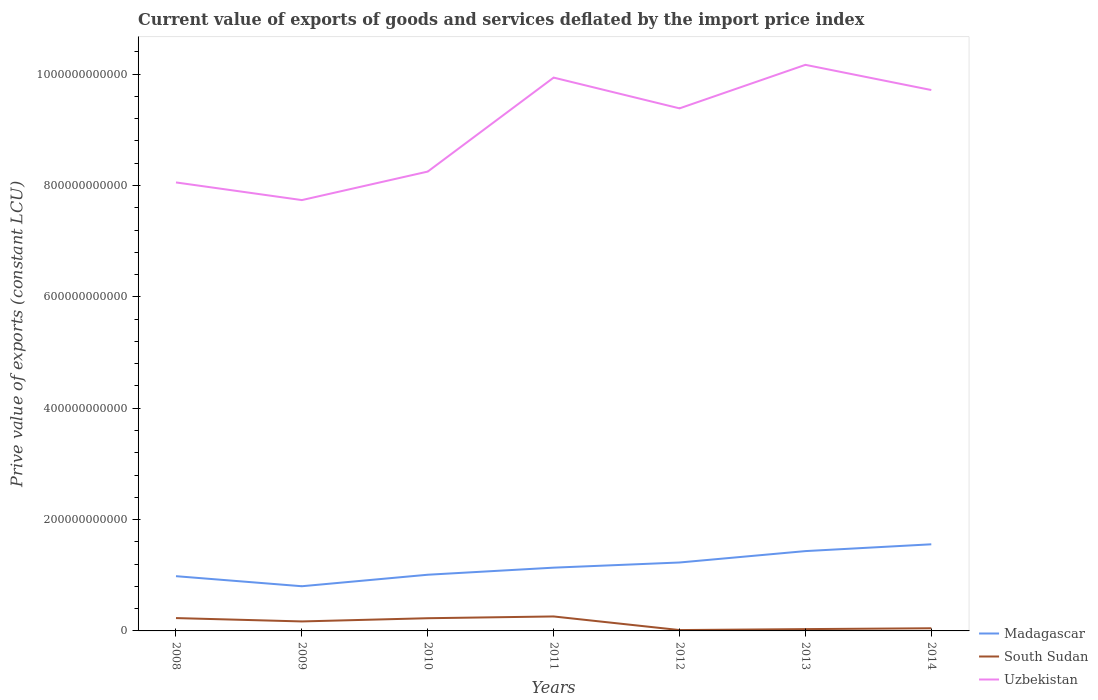How many different coloured lines are there?
Give a very brief answer. 3. Across all years, what is the maximum prive value of exports in South Sudan?
Your response must be concise. 1.55e+09. In which year was the prive value of exports in Uzbekistan maximum?
Make the answer very short. 2009. What is the total prive value of exports in South Sudan in the graph?
Offer a terse response. 2.44e+1. What is the difference between the highest and the second highest prive value of exports in Uzbekistan?
Keep it short and to the point. 2.43e+11. How many lines are there?
Keep it short and to the point. 3. How many years are there in the graph?
Ensure brevity in your answer.  7. What is the difference between two consecutive major ticks on the Y-axis?
Keep it short and to the point. 2.00e+11. Are the values on the major ticks of Y-axis written in scientific E-notation?
Make the answer very short. No. Does the graph contain any zero values?
Offer a very short reply. No. Does the graph contain grids?
Provide a succinct answer. No. Where does the legend appear in the graph?
Make the answer very short. Bottom right. How are the legend labels stacked?
Your answer should be compact. Vertical. What is the title of the graph?
Offer a very short reply. Current value of exports of goods and services deflated by the import price index. What is the label or title of the Y-axis?
Give a very brief answer. Prive value of exports (constant LCU). What is the Prive value of exports (constant LCU) in Madagascar in 2008?
Your answer should be compact. 9.83e+1. What is the Prive value of exports (constant LCU) of South Sudan in 2008?
Your response must be concise. 2.31e+1. What is the Prive value of exports (constant LCU) of Uzbekistan in 2008?
Keep it short and to the point. 8.05e+11. What is the Prive value of exports (constant LCU) in Madagascar in 2009?
Offer a terse response. 8.03e+1. What is the Prive value of exports (constant LCU) in South Sudan in 2009?
Offer a terse response. 1.70e+1. What is the Prive value of exports (constant LCU) in Uzbekistan in 2009?
Ensure brevity in your answer.  7.74e+11. What is the Prive value of exports (constant LCU) in Madagascar in 2010?
Provide a succinct answer. 1.01e+11. What is the Prive value of exports (constant LCU) in South Sudan in 2010?
Provide a short and direct response. 2.28e+1. What is the Prive value of exports (constant LCU) of Uzbekistan in 2010?
Your answer should be very brief. 8.25e+11. What is the Prive value of exports (constant LCU) of Madagascar in 2011?
Provide a succinct answer. 1.14e+11. What is the Prive value of exports (constant LCU) of South Sudan in 2011?
Keep it short and to the point. 2.60e+1. What is the Prive value of exports (constant LCU) of Uzbekistan in 2011?
Offer a very short reply. 9.94e+11. What is the Prive value of exports (constant LCU) of Madagascar in 2012?
Ensure brevity in your answer.  1.23e+11. What is the Prive value of exports (constant LCU) in South Sudan in 2012?
Your answer should be compact. 1.55e+09. What is the Prive value of exports (constant LCU) of Uzbekistan in 2012?
Keep it short and to the point. 9.38e+11. What is the Prive value of exports (constant LCU) of Madagascar in 2013?
Offer a terse response. 1.43e+11. What is the Prive value of exports (constant LCU) in South Sudan in 2013?
Offer a terse response. 3.25e+09. What is the Prive value of exports (constant LCU) of Uzbekistan in 2013?
Make the answer very short. 1.02e+12. What is the Prive value of exports (constant LCU) of Madagascar in 2014?
Your response must be concise. 1.56e+11. What is the Prive value of exports (constant LCU) of South Sudan in 2014?
Your answer should be very brief. 4.76e+09. What is the Prive value of exports (constant LCU) in Uzbekistan in 2014?
Offer a terse response. 9.71e+11. Across all years, what is the maximum Prive value of exports (constant LCU) of Madagascar?
Provide a short and direct response. 1.56e+11. Across all years, what is the maximum Prive value of exports (constant LCU) in South Sudan?
Make the answer very short. 2.60e+1. Across all years, what is the maximum Prive value of exports (constant LCU) in Uzbekistan?
Offer a very short reply. 1.02e+12. Across all years, what is the minimum Prive value of exports (constant LCU) of Madagascar?
Give a very brief answer. 8.03e+1. Across all years, what is the minimum Prive value of exports (constant LCU) of South Sudan?
Provide a succinct answer. 1.55e+09. Across all years, what is the minimum Prive value of exports (constant LCU) in Uzbekistan?
Make the answer very short. 7.74e+11. What is the total Prive value of exports (constant LCU) in Madagascar in the graph?
Provide a short and direct response. 8.15e+11. What is the total Prive value of exports (constant LCU) in South Sudan in the graph?
Offer a terse response. 9.85e+1. What is the total Prive value of exports (constant LCU) of Uzbekistan in the graph?
Your response must be concise. 6.32e+12. What is the difference between the Prive value of exports (constant LCU) in Madagascar in 2008 and that in 2009?
Make the answer very short. 1.81e+1. What is the difference between the Prive value of exports (constant LCU) in South Sudan in 2008 and that in 2009?
Offer a very short reply. 6.03e+09. What is the difference between the Prive value of exports (constant LCU) of Uzbekistan in 2008 and that in 2009?
Your response must be concise. 3.17e+1. What is the difference between the Prive value of exports (constant LCU) in Madagascar in 2008 and that in 2010?
Keep it short and to the point. -2.60e+09. What is the difference between the Prive value of exports (constant LCU) in South Sudan in 2008 and that in 2010?
Your answer should be very brief. 2.50e+08. What is the difference between the Prive value of exports (constant LCU) of Uzbekistan in 2008 and that in 2010?
Your answer should be very brief. -1.95e+1. What is the difference between the Prive value of exports (constant LCU) of Madagascar in 2008 and that in 2011?
Your answer should be very brief. -1.53e+1. What is the difference between the Prive value of exports (constant LCU) of South Sudan in 2008 and that in 2011?
Give a very brief answer. -2.90e+09. What is the difference between the Prive value of exports (constant LCU) of Uzbekistan in 2008 and that in 2011?
Keep it short and to the point. -1.88e+11. What is the difference between the Prive value of exports (constant LCU) in Madagascar in 2008 and that in 2012?
Provide a short and direct response. -2.46e+1. What is the difference between the Prive value of exports (constant LCU) in South Sudan in 2008 and that in 2012?
Make the answer very short. 2.15e+1. What is the difference between the Prive value of exports (constant LCU) in Uzbekistan in 2008 and that in 2012?
Keep it short and to the point. -1.33e+11. What is the difference between the Prive value of exports (constant LCU) in Madagascar in 2008 and that in 2013?
Your response must be concise. -4.50e+1. What is the difference between the Prive value of exports (constant LCU) in South Sudan in 2008 and that in 2013?
Ensure brevity in your answer.  1.98e+1. What is the difference between the Prive value of exports (constant LCU) of Uzbekistan in 2008 and that in 2013?
Your response must be concise. -2.11e+11. What is the difference between the Prive value of exports (constant LCU) in Madagascar in 2008 and that in 2014?
Give a very brief answer. -5.73e+1. What is the difference between the Prive value of exports (constant LCU) in South Sudan in 2008 and that in 2014?
Provide a succinct answer. 1.83e+1. What is the difference between the Prive value of exports (constant LCU) in Uzbekistan in 2008 and that in 2014?
Provide a short and direct response. -1.66e+11. What is the difference between the Prive value of exports (constant LCU) in Madagascar in 2009 and that in 2010?
Your answer should be very brief. -2.06e+1. What is the difference between the Prive value of exports (constant LCU) in South Sudan in 2009 and that in 2010?
Your answer should be very brief. -5.78e+09. What is the difference between the Prive value of exports (constant LCU) of Uzbekistan in 2009 and that in 2010?
Your answer should be very brief. -5.12e+1. What is the difference between the Prive value of exports (constant LCU) of Madagascar in 2009 and that in 2011?
Make the answer very short. -3.34e+1. What is the difference between the Prive value of exports (constant LCU) in South Sudan in 2009 and that in 2011?
Your response must be concise. -8.93e+09. What is the difference between the Prive value of exports (constant LCU) of Uzbekistan in 2009 and that in 2011?
Provide a short and direct response. -2.20e+11. What is the difference between the Prive value of exports (constant LCU) of Madagascar in 2009 and that in 2012?
Give a very brief answer. -4.26e+1. What is the difference between the Prive value of exports (constant LCU) of South Sudan in 2009 and that in 2012?
Offer a very short reply. 1.55e+1. What is the difference between the Prive value of exports (constant LCU) of Uzbekistan in 2009 and that in 2012?
Your answer should be very brief. -1.65e+11. What is the difference between the Prive value of exports (constant LCU) of Madagascar in 2009 and that in 2013?
Offer a terse response. -6.31e+1. What is the difference between the Prive value of exports (constant LCU) in South Sudan in 2009 and that in 2013?
Keep it short and to the point. 1.38e+1. What is the difference between the Prive value of exports (constant LCU) in Uzbekistan in 2009 and that in 2013?
Provide a succinct answer. -2.43e+11. What is the difference between the Prive value of exports (constant LCU) in Madagascar in 2009 and that in 2014?
Offer a very short reply. -7.53e+1. What is the difference between the Prive value of exports (constant LCU) in South Sudan in 2009 and that in 2014?
Make the answer very short. 1.23e+1. What is the difference between the Prive value of exports (constant LCU) in Uzbekistan in 2009 and that in 2014?
Offer a very short reply. -1.98e+11. What is the difference between the Prive value of exports (constant LCU) in Madagascar in 2010 and that in 2011?
Keep it short and to the point. -1.27e+1. What is the difference between the Prive value of exports (constant LCU) of South Sudan in 2010 and that in 2011?
Provide a succinct answer. -3.15e+09. What is the difference between the Prive value of exports (constant LCU) in Uzbekistan in 2010 and that in 2011?
Provide a short and direct response. -1.69e+11. What is the difference between the Prive value of exports (constant LCU) of Madagascar in 2010 and that in 2012?
Keep it short and to the point. -2.20e+1. What is the difference between the Prive value of exports (constant LCU) in South Sudan in 2010 and that in 2012?
Offer a very short reply. 2.13e+1. What is the difference between the Prive value of exports (constant LCU) of Uzbekistan in 2010 and that in 2012?
Make the answer very short. -1.14e+11. What is the difference between the Prive value of exports (constant LCU) of Madagascar in 2010 and that in 2013?
Your answer should be compact. -4.25e+1. What is the difference between the Prive value of exports (constant LCU) in South Sudan in 2010 and that in 2013?
Offer a very short reply. 1.96e+1. What is the difference between the Prive value of exports (constant LCU) in Uzbekistan in 2010 and that in 2013?
Make the answer very short. -1.92e+11. What is the difference between the Prive value of exports (constant LCU) of Madagascar in 2010 and that in 2014?
Your response must be concise. -5.47e+1. What is the difference between the Prive value of exports (constant LCU) in South Sudan in 2010 and that in 2014?
Offer a very short reply. 1.81e+1. What is the difference between the Prive value of exports (constant LCU) of Uzbekistan in 2010 and that in 2014?
Keep it short and to the point. -1.46e+11. What is the difference between the Prive value of exports (constant LCU) of Madagascar in 2011 and that in 2012?
Provide a short and direct response. -9.28e+09. What is the difference between the Prive value of exports (constant LCU) in South Sudan in 2011 and that in 2012?
Give a very brief answer. 2.44e+1. What is the difference between the Prive value of exports (constant LCU) of Uzbekistan in 2011 and that in 2012?
Your response must be concise. 5.53e+1. What is the difference between the Prive value of exports (constant LCU) in Madagascar in 2011 and that in 2013?
Your answer should be compact. -2.97e+1. What is the difference between the Prive value of exports (constant LCU) of South Sudan in 2011 and that in 2013?
Provide a succinct answer. 2.27e+1. What is the difference between the Prive value of exports (constant LCU) of Uzbekistan in 2011 and that in 2013?
Ensure brevity in your answer.  -2.29e+1. What is the difference between the Prive value of exports (constant LCU) in Madagascar in 2011 and that in 2014?
Your answer should be compact. -4.20e+1. What is the difference between the Prive value of exports (constant LCU) in South Sudan in 2011 and that in 2014?
Offer a terse response. 2.12e+1. What is the difference between the Prive value of exports (constant LCU) in Uzbekistan in 2011 and that in 2014?
Provide a short and direct response. 2.23e+1. What is the difference between the Prive value of exports (constant LCU) in Madagascar in 2012 and that in 2013?
Offer a very short reply. -2.05e+1. What is the difference between the Prive value of exports (constant LCU) of South Sudan in 2012 and that in 2013?
Ensure brevity in your answer.  -1.70e+09. What is the difference between the Prive value of exports (constant LCU) of Uzbekistan in 2012 and that in 2013?
Offer a very short reply. -7.82e+1. What is the difference between the Prive value of exports (constant LCU) in Madagascar in 2012 and that in 2014?
Ensure brevity in your answer.  -3.27e+1. What is the difference between the Prive value of exports (constant LCU) of South Sudan in 2012 and that in 2014?
Offer a terse response. -3.22e+09. What is the difference between the Prive value of exports (constant LCU) in Uzbekistan in 2012 and that in 2014?
Your answer should be very brief. -3.29e+1. What is the difference between the Prive value of exports (constant LCU) in Madagascar in 2013 and that in 2014?
Offer a terse response. -1.22e+1. What is the difference between the Prive value of exports (constant LCU) in South Sudan in 2013 and that in 2014?
Your answer should be very brief. -1.51e+09. What is the difference between the Prive value of exports (constant LCU) in Uzbekistan in 2013 and that in 2014?
Keep it short and to the point. 4.52e+1. What is the difference between the Prive value of exports (constant LCU) of Madagascar in 2008 and the Prive value of exports (constant LCU) of South Sudan in 2009?
Your response must be concise. 8.13e+1. What is the difference between the Prive value of exports (constant LCU) in Madagascar in 2008 and the Prive value of exports (constant LCU) in Uzbekistan in 2009?
Keep it short and to the point. -6.75e+11. What is the difference between the Prive value of exports (constant LCU) in South Sudan in 2008 and the Prive value of exports (constant LCU) in Uzbekistan in 2009?
Keep it short and to the point. -7.51e+11. What is the difference between the Prive value of exports (constant LCU) of Madagascar in 2008 and the Prive value of exports (constant LCU) of South Sudan in 2010?
Provide a short and direct response. 7.55e+1. What is the difference between the Prive value of exports (constant LCU) of Madagascar in 2008 and the Prive value of exports (constant LCU) of Uzbekistan in 2010?
Give a very brief answer. -7.27e+11. What is the difference between the Prive value of exports (constant LCU) of South Sudan in 2008 and the Prive value of exports (constant LCU) of Uzbekistan in 2010?
Your response must be concise. -8.02e+11. What is the difference between the Prive value of exports (constant LCU) in Madagascar in 2008 and the Prive value of exports (constant LCU) in South Sudan in 2011?
Your response must be concise. 7.23e+1. What is the difference between the Prive value of exports (constant LCU) in Madagascar in 2008 and the Prive value of exports (constant LCU) in Uzbekistan in 2011?
Provide a short and direct response. -8.95e+11. What is the difference between the Prive value of exports (constant LCU) of South Sudan in 2008 and the Prive value of exports (constant LCU) of Uzbekistan in 2011?
Keep it short and to the point. -9.71e+11. What is the difference between the Prive value of exports (constant LCU) in Madagascar in 2008 and the Prive value of exports (constant LCU) in South Sudan in 2012?
Offer a very short reply. 9.68e+1. What is the difference between the Prive value of exports (constant LCU) in Madagascar in 2008 and the Prive value of exports (constant LCU) in Uzbekistan in 2012?
Keep it short and to the point. -8.40e+11. What is the difference between the Prive value of exports (constant LCU) in South Sudan in 2008 and the Prive value of exports (constant LCU) in Uzbekistan in 2012?
Keep it short and to the point. -9.15e+11. What is the difference between the Prive value of exports (constant LCU) of Madagascar in 2008 and the Prive value of exports (constant LCU) of South Sudan in 2013?
Provide a short and direct response. 9.51e+1. What is the difference between the Prive value of exports (constant LCU) of Madagascar in 2008 and the Prive value of exports (constant LCU) of Uzbekistan in 2013?
Ensure brevity in your answer.  -9.18e+11. What is the difference between the Prive value of exports (constant LCU) in South Sudan in 2008 and the Prive value of exports (constant LCU) in Uzbekistan in 2013?
Your answer should be compact. -9.94e+11. What is the difference between the Prive value of exports (constant LCU) in Madagascar in 2008 and the Prive value of exports (constant LCU) in South Sudan in 2014?
Keep it short and to the point. 9.36e+1. What is the difference between the Prive value of exports (constant LCU) in Madagascar in 2008 and the Prive value of exports (constant LCU) in Uzbekistan in 2014?
Provide a succinct answer. -8.73e+11. What is the difference between the Prive value of exports (constant LCU) in South Sudan in 2008 and the Prive value of exports (constant LCU) in Uzbekistan in 2014?
Provide a succinct answer. -9.48e+11. What is the difference between the Prive value of exports (constant LCU) of Madagascar in 2009 and the Prive value of exports (constant LCU) of South Sudan in 2010?
Offer a very short reply. 5.74e+1. What is the difference between the Prive value of exports (constant LCU) in Madagascar in 2009 and the Prive value of exports (constant LCU) in Uzbekistan in 2010?
Provide a succinct answer. -7.45e+11. What is the difference between the Prive value of exports (constant LCU) of South Sudan in 2009 and the Prive value of exports (constant LCU) of Uzbekistan in 2010?
Offer a terse response. -8.08e+11. What is the difference between the Prive value of exports (constant LCU) of Madagascar in 2009 and the Prive value of exports (constant LCU) of South Sudan in 2011?
Give a very brief answer. 5.43e+1. What is the difference between the Prive value of exports (constant LCU) in Madagascar in 2009 and the Prive value of exports (constant LCU) in Uzbekistan in 2011?
Ensure brevity in your answer.  -9.13e+11. What is the difference between the Prive value of exports (constant LCU) in South Sudan in 2009 and the Prive value of exports (constant LCU) in Uzbekistan in 2011?
Ensure brevity in your answer.  -9.77e+11. What is the difference between the Prive value of exports (constant LCU) in Madagascar in 2009 and the Prive value of exports (constant LCU) in South Sudan in 2012?
Provide a short and direct response. 7.87e+1. What is the difference between the Prive value of exports (constant LCU) in Madagascar in 2009 and the Prive value of exports (constant LCU) in Uzbekistan in 2012?
Ensure brevity in your answer.  -8.58e+11. What is the difference between the Prive value of exports (constant LCU) in South Sudan in 2009 and the Prive value of exports (constant LCU) in Uzbekistan in 2012?
Give a very brief answer. -9.21e+11. What is the difference between the Prive value of exports (constant LCU) in Madagascar in 2009 and the Prive value of exports (constant LCU) in South Sudan in 2013?
Your response must be concise. 7.70e+1. What is the difference between the Prive value of exports (constant LCU) in Madagascar in 2009 and the Prive value of exports (constant LCU) in Uzbekistan in 2013?
Your response must be concise. -9.36e+11. What is the difference between the Prive value of exports (constant LCU) of South Sudan in 2009 and the Prive value of exports (constant LCU) of Uzbekistan in 2013?
Your answer should be compact. -1.00e+12. What is the difference between the Prive value of exports (constant LCU) of Madagascar in 2009 and the Prive value of exports (constant LCU) of South Sudan in 2014?
Offer a terse response. 7.55e+1. What is the difference between the Prive value of exports (constant LCU) in Madagascar in 2009 and the Prive value of exports (constant LCU) in Uzbekistan in 2014?
Provide a short and direct response. -8.91e+11. What is the difference between the Prive value of exports (constant LCU) in South Sudan in 2009 and the Prive value of exports (constant LCU) in Uzbekistan in 2014?
Provide a succinct answer. -9.54e+11. What is the difference between the Prive value of exports (constant LCU) in Madagascar in 2010 and the Prive value of exports (constant LCU) in South Sudan in 2011?
Your response must be concise. 7.49e+1. What is the difference between the Prive value of exports (constant LCU) of Madagascar in 2010 and the Prive value of exports (constant LCU) of Uzbekistan in 2011?
Your response must be concise. -8.93e+11. What is the difference between the Prive value of exports (constant LCU) in South Sudan in 2010 and the Prive value of exports (constant LCU) in Uzbekistan in 2011?
Make the answer very short. -9.71e+11. What is the difference between the Prive value of exports (constant LCU) of Madagascar in 2010 and the Prive value of exports (constant LCU) of South Sudan in 2012?
Your response must be concise. 9.94e+1. What is the difference between the Prive value of exports (constant LCU) of Madagascar in 2010 and the Prive value of exports (constant LCU) of Uzbekistan in 2012?
Your response must be concise. -8.38e+11. What is the difference between the Prive value of exports (constant LCU) in South Sudan in 2010 and the Prive value of exports (constant LCU) in Uzbekistan in 2012?
Offer a terse response. -9.16e+11. What is the difference between the Prive value of exports (constant LCU) in Madagascar in 2010 and the Prive value of exports (constant LCU) in South Sudan in 2013?
Offer a very short reply. 9.77e+1. What is the difference between the Prive value of exports (constant LCU) of Madagascar in 2010 and the Prive value of exports (constant LCU) of Uzbekistan in 2013?
Ensure brevity in your answer.  -9.16e+11. What is the difference between the Prive value of exports (constant LCU) in South Sudan in 2010 and the Prive value of exports (constant LCU) in Uzbekistan in 2013?
Your answer should be very brief. -9.94e+11. What is the difference between the Prive value of exports (constant LCU) of Madagascar in 2010 and the Prive value of exports (constant LCU) of South Sudan in 2014?
Your answer should be very brief. 9.61e+1. What is the difference between the Prive value of exports (constant LCU) of Madagascar in 2010 and the Prive value of exports (constant LCU) of Uzbekistan in 2014?
Give a very brief answer. -8.71e+11. What is the difference between the Prive value of exports (constant LCU) in South Sudan in 2010 and the Prive value of exports (constant LCU) in Uzbekistan in 2014?
Provide a short and direct response. -9.49e+11. What is the difference between the Prive value of exports (constant LCU) of Madagascar in 2011 and the Prive value of exports (constant LCU) of South Sudan in 2012?
Provide a succinct answer. 1.12e+11. What is the difference between the Prive value of exports (constant LCU) in Madagascar in 2011 and the Prive value of exports (constant LCU) in Uzbekistan in 2012?
Offer a very short reply. -8.25e+11. What is the difference between the Prive value of exports (constant LCU) of South Sudan in 2011 and the Prive value of exports (constant LCU) of Uzbekistan in 2012?
Your answer should be compact. -9.13e+11. What is the difference between the Prive value of exports (constant LCU) of Madagascar in 2011 and the Prive value of exports (constant LCU) of South Sudan in 2013?
Provide a succinct answer. 1.10e+11. What is the difference between the Prive value of exports (constant LCU) of Madagascar in 2011 and the Prive value of exports (constant LCU) of Uzbekistan in 2013?
Keep it short and to the point. -9.03e+11. What is the difference between the Prive value of exports (constant LCU) of South Sudan in 2011 and the Prive value of exports (constant LCU) of Uzbekistan in 2013?
Offer a very short reply. -9.91e+11. What is the difference between the Prive value of exports (constant LCU) in Madagascar in 2011 and the Prive value of exports (constant LCU) in South Sudan in 2014?
Keep it short and to the point. 1.09e+11. What is the difference between the Prive value of exports (constant LCU) of Madagascar in 2011 and the Prive value of exports (constant LCU) of Uzbekistan in 2014?
Provide a succinct answer. -8.58e+11. What is the difference between the Prive value of exports (constant LCU) in South Sudan in 2011 and the Prive value of exports (constant LCU) in Uzbekistan in 2014?
Provide a succinct answer. -9.45e+11. What is the difference between the Prive value of exports (constant LCU) in Madagascar in 2012 and the Prive value of exports (constant LCU) in South Sudan in 2013?
Make the answer very short. 1.20e+11. What is the difference between the Prive value of exports (constant LCU) in Madagascar in 2012 and the Prive value of exports (constant LCU) in Uzbekistan in 2013?
Offer a terse response. -8.94e+11. What is the difference between the Prive value of exports (constant LCU) of South Sudan in 2012 and the Prive value of exports (constant LCU) of Uzbekistan in 2013?
Make the answer very short. -1.02e+12. What is the difference between the Prive value of exports (constant LCU) of Madagascar in 2012 and the Prive value of exports (constant LCU) of South Sudan in 2014?
Offer a very short reply. 1.18e+11. What is the difference between the Prive value of exports (constant LCU) in Madagascar in 2012 and the Prive value of exports (constant LCU) in Uzbekistan in 2014?
Your response must be concise. -8.49e+11. What is the difference between the Prive value of exports (constant LCU) of South Sudan in 2012 and the Prive value of exports (constant LCU) of Uzbekistan in 2014?
Provide a short and direct response. -9.70e+11. What is the difference between the Prive value of exports (constant LCU) of Madagascar in 2013 and the Prive value of exports (constant LCU) of South Sudan in 2014?
Keep it short and to the point. 1.39e+11. What is the difference between the Prive value of exports (constant LCU) in Madagascar in 2013 and the Prive value of exports (constant LCU) in Uzbekistan in 2014?
Provide a short and direct response. -8.28e+11. What is the difference between the Prive value of exports (constant LCU) of South Sudan in 2013 and the Prive value of exports (constant LCU) of Uzbekistan in 2014?
Your answer should be very brief. -9.68e+11. What is the average Prive value of exports (constant LCU) in Madagascar per year?
Offer a terse response. 1.16e+11. What is the average Prive value of exports (constant LCU) of South Sudan per year?
Provide a short and direct response. 1.41e+1. What is the average Prive value of exports (constant LCU) of Uzbekistan per year?
Provide a succinct answer. 9.04e+11. In the year 2008, what is the difference between the Prive value of exports (constant LCU) in Madagascar and Prive value of exports (constant LCU) in South Sudan?
Keep it short and to the point. 7.52e+1. In the year 2008, what is the difference between the Prive value of exports (constant LCU) of Madagascar and Prive value of exports (constant LCU) of Uzbekistan?
Provide a succinct answer. -7.07e+11. In the year 2008, what is the difference between the Prive value of exports (constant LCU) in South Sudan and Prive value of exports (constant LCU) in Uzbekistan?
Your answer should be compact. -7.82e+11. In the year 2009, what is the difference between the Prive value of exports (constant LCU) of Madagascar and Prive value of exports (constant LCU) of South Sudan?
Offer a terse response. 6.32e+1. In the year 2009, what is the difference between the Prive value of exports (constant LCU) of Madagascar and Prive value of exports (constant LCU) of Uzbekistan?
Keep it short and to the point. -6.93e+11. In the year 2009, what is the difference between the Prive value of exports (constant LCU) of South Sudan and Prive value of exports (constant LCU) of Uzbekistan?
Provide a short and direct response. -7.57e+11. In the year 2010, what is the difference between the Prive value of exports (constant LCU) in Madagascar and Prive value of exports (constant LCU) in South Sudan?
Provide a succinct answer. 7.81e+1. In the year 2010, what is the difference between the Prive value of exports (constant LCU) of Madagascar and Prive value of exports (constant LCU) of Uzbekistan?
Provide a succinct answer. -7.24e+11. In the year 2010, what is the difference between the Prive value of exports (constant LCU) in South Sudan and Prive value of exports (constant LCU) in Uzbekistan?
Ensure brevity in your answer.  -8.02e+11. In the year 2011, what is the difference between the Prive value of exports (constant LCU) of Madagascar and Prive value of exports (constant LCU) of South Sudan?
Provide a succinct answer. 8.76e+1. In the year 2011, what is the difference between the Prive value of exports (constant LCU) of Madagascar and Prive value of exports (constant LCU) of Uzbekistan?
Provide a short and direct response. -8.80e+11. In the year 2011, what is the difference between the Prive value of exports (constant LCU) in South Sudan and Prive value of exports (constant LCU) in Uzbekistan?
Offer a terse response. -9.68e+11. In the year 2012, what is the difference between the Prive value of exports (constant LCU) of Madagascar and Prive value of exports (constant LCU) of South Sudan?
Provide a short and direct response. 1.21e+11. In the year 2012, what is the difference between the Prive value of exports (constant LCU) in Madagascar and Prive value of exports (constant LCU) in Uzbekistan?
Your answer should be very brief. -8.16e+11. In the year 2012, what is the difference between the Prive value of exports (constant LCU) in South Sudan and Prive value of exports (constant LCU) in Uzbekistan?
Your answer should be very brief. -9.37e+11. In the year 2013, what is the difference between the Prive value of exports (constant LCU) of Madagascar and Prive value of exports (constant LCU) of South Sudan?
Ensure brevity in your answer.  1.40e+11. In the year 2013, what is the difference between the Prive value of exports (constant LCU) in Madagascar and Prive value of exports (constant LCU) in Uzbekistan?
Offer a terse response. -8.73e+11. In the year 2013, what is the difference between the Prive value of exports (constant LCU) in South Sudan and Prive value of exports (constant LCU) in Uzbekistan?
Your answer should be compact. -1.01e+12. In the year 2014, what is the difference between the Prive value of exports (constant LCU) in Madagascar and Prive value of exports (constant LCU) in South Sudan?
Your answer should be very brief. 1.51e+11. In the year 2014, what is the difference between the Prive value of exports (constant LCU) of Madagascar and Prive value of exports (constant LCU) of Uzbekistan?
Keep it short and to the point. -8.16e+11. In the year 2014, what is the difference between the Prive value of exports (constant LCU) in South Sudan and Prive value of exports (constant LCU) in Uzbekistan?
Make the answer very short. -9.67e+11. What is the ratio of the Prive value of exports (constant LCU) in Madagascar in 2008 to that in 2009?
Offer a terse response. 1.22. What is the ratio of the Prive value of exports (constant LCU) of South Sudan in 2008 to that in 2009?
Keep it short and to the point. 1.35. What is the ratio of the Prive value of exports (constant LCU) in Uzbekistan in 2008 to that in 2009?
Provide a succinct answer. 1.04. What is the ratio of the Prive value of exports (constant LCU) in Madagascar in 2008 to that in 2010?
Ensure brevity in your answer.  0.97. What is the ratio of the Prive value of exports (constant LCU) in Uzbekistan in 2008 to that in 2010?
Ensure brevity in your answer.  0.98. What is the ratio of the Prive value of exports (constant LCU) in Madagascar in 2008 to that in 2011?
Your answer should be very brief. 0.87. What is the ratio of the Prive value of exports (constant LCU) in South Sudan in 2008 to that in 2011?
Offer a very short reply. 0.89. What is the ratio of the Prive value of exports (constant LCU) in Uzbekistan in 2008 to that in 2011?
Make the answer very short. 0.81. What is the ratio of the Prive value of exports (constant LCU) in Madagascar in 2008 to that in 2012?
Give a very brief answer. 0.8. What is the ratio of the Prive value of exports (constant LCU) in South Sudan in 2008 to that in 2012?
Keep it short and to the point. 14.93. What is the ratio of the Prive value of exports (constant LCU) of Uzbekistan in 2008 to that in 2012?
Make the answer very short. 0.86. What is the ratio of the Prive value of exports (constant LCU) of Madagascar in 2008 to that in 2013?
Provide a short and direct response. 0.69. What is the ratio of the Prive value of exports (constant LCU) of South Sudan in 2008 to that in 2013?
Ensure brevity in your answer.  7.1. What is the ratio of the Prive value of exports (constant LCU) in Uzbekistan in 2008 to that in 2013?
Ensure brevity in your answer.  0.79. What is the ratio of the Prive value of exports (constant LCU) in Madagascar in 2008 to that in 2014?
Provide a short and direct response. 0.63. What is the ratio of the Prive value of exports (constant LCU) in South Sudan in 2008 to that in 2014?
Provide a succinct answer. 4.84. What is the ratio of the Prive value of exports (constant LCU) in Uzbekistan in 2008 to that in 2014?
Make the answer very short. 0.83. What is the ratio of the Prive value of exports (constant LCU) of Madagascar in 2009 to that in 2010?
Your response must be concise. 0.8. What is the ratio of the Prive value of exports (constant LCU) in South Sudan in 2009 to that in 2010?
Your answer should be very brief. 0.75. What is the ratio of the Prive value of exports (constant LCU) in Uzbekistan in 2009 to that in 2010?
Make the answer very short. 0.94. What is the ratio of the Prive value of exports (constant LCU) of Madagascar in 2009 to that in 2011?
Offer a terse response. 0.71. What is the ratio of the Prive value of exports (constant LCU) of South Sudan in 2009 to that in 2011?
Keep it short and to the point. 0.66. What is the ratio of the Prive value of exports (constant LCU) of Uzbekistan in 2009 to that in 2011?
Your answer should be compact. 0.78. What is the ratio of the Prive value of exports (constant LCU) in Madagascar in 2009 to that in 2012?
Your answer should be very brief. 0.65. What is the ratio of the Prive value of exports (constant LCU) in South Sudan in 2009 to that in 2012?
Your answer should be very brief. 11.03. What is the ratio of the Prive value of exports (constant LCU) of Uzbekistan in 2009 to that in 2012?
Keep it short and to the point. 0.82. What is the ratio of the Prive value of exports (constant LCU) of Madagascar in 2009 to that in 2013?
Your response must be concise. 0.56. What is the ratio of the Prive value of exports (constant LCU) in South Sudan in 2009 to that in 2013?
Give a very brief answer. 5.25. What is the ratio of the Prive value of exports (constant LCU) in Uzbekistan in 2009 to that in 2013?
Provide a short and direct response. 0.76. What is the ratio of the Prive value of exports (constant LCU) of Madagascar in 2009 to that in 2014?
Make the answer very short. 0.52. What is the ratio of the Prive value of exports (constant LCU) of South Sudan in 2009 to that in 2014?
Offer a terse response. 3.58. What is the ratio of the Prive value of exports (constant LCU) of Uzbekistan in 2009 to that in 2014?
Your answer should be very brief. 0.8. What is the ratio of the Prive value of exports (constant LCU) of Madagascar in 2010 to that in 2011?
Make the answer very short. 0.89. What is the ratio of the Prive value of exports (constant LCU) in South Sudan in 2010 to that in 2011?
Your answer should be compact. 0.88. What is the ratio of the Prive value of exports (constant LCU) in Uzbekistan in 2010 to that in 2011?
Ensure brevity in your answer.  0.83. What is the ratio of the Prive value of exports (constant LCU) in Madagascar in 2010 to that in 2012?
Offer a very short reply. 0.82. What is the ratio of the Prive value of exports (constant LCU) in South Sudan in 2010 to that in 2012?
Make the answer very short. 14.77. What is the ratio of the Prive value of exports (constant LCU) in Uzbekistan in 2010 to that in 2012?
Offer a very short reply. 0.88. What is the ratio of the Prive value of exports (constant LCU) of Madagascar in 2010 to that in 2013?
Your answer should be very brief. 0.7. What is the ratio of the Prive value of exports (constant LCU) of South Sudan in 2010 to that in 2013?
Your answer should be compact. 7.03. What is the ratio of the Prive value of exports (constant LCU) of Uzbekistan in 2010 to that in 2013?
Your answer should be compact. 0.81. What is the ratio of the Prive value of exports (constant LCU) of Madagascar in 2010 to that in 2014?
Provide a succinct answer. 0.65. What is the ratio of the Prive value of exports (constant LCU) in South Sudan in 2010 to that in 2014?
Your answer should be compact. 4.79. What is the ratio of the Prive value of exports (constant LCU) in Uzbekistan in 2010 to that in 2014?
Ensure brevity in your answer.  0.85. What is the ratio of the Prive value of exports (constant LCU) of Madagascar in 2011 to that in 2012?
Make the answer very short. 0.92. What is the ratio of the Prive value of exports (constant LCU) of South Sudan in 2011 to that in 2012?
Keep it short and to the point. 16.81. What is the ratio of the Prive value of exports (constant LCU) in Uzbekistan in 2011 to that in 2012?
Keep it short and to the point. 1.06. What is the ratio of the Prive value of exports (constant LCU) in Madagascar in 2011 to that in 2013?
Your response must be concise. 0.79. What is the ratio of the Prive value of exports (constant LCU) in South Sudan in 2011 to that in 2013?
Keep it short and to the point. 8. What is the ratio of the Prive value of exports (constant LCU) of Uzbekistan in 2011 to that in 2013?
Your answer should be very brief. 0.98. What is the ratio of the Prive value of exports (constant LCU) of Madagascar in 2011 to that in 2014?
Your answer should be very brief. 0.73. What is the ratio of the Prive value of exports (constant LCU) of South Sudan in 2011 to that in 2014?
Offer a terse response. 5.45. What is the ratio of the Prive value of exports (constant LCU) of Madagascar in 2012 to that in 2013?
Your answer should be compact. 0.86. What is the ratio of the Prive value of exports (constant LCU) of South Sudan in 2012 to that in 2013?
Make the answer very short. 0.48. What is the ratio of the Prive value of exports (constant LCU) of Uzbekistan in 2012 to that in 2013?
Your answer should be compact. 0.92. What is the ratio of the Prive value of exports (constant LCU) of Madagascar in 2012 to that in 2014?
Make the answer very short. 0.79. What is the ratio of the Prive value of exports (constant LCU) of South Sudan in 2012 to that in 2014?
Offer a very short reply. 0.32. What is the ratio of the Prive value of exports (constant LCU) of Uzbekistan in 2012 to that in 2014?
Provide a short and direct response. 0.97. What is the ratio of the Prive value of exports (constant LCU) of Madagascar in 2013 to that in 2014?
Offer a very short reply. 0.92. What is the ratio of the Prive value of exports (constant LCU) in South Sudan in 2013 to that in 2014?
Give a very brief answer. 0.68. What is the ratio of the Prive value of exports (constant LCU) in Uzbekistan in 2013 to that in 2014?
Give a very brief answer. 1.05. What is the difference between the highest and the second highest Prive value of exports (constant LCU) in Madagascar?
Give a very brief answer. 1.22e+1. What is the difference between the highest and the second highest Prive value of exports (constant LCU) in South Sudan?
Provide a succinct answer. 2.90e+09. What is the difference between the highest and the second highest Prive value of exports (constant LCU) in Uzbekistan?
Make the answer very short. 2.29e+1. What is the difference between the highest and the lowest Prive value of exports (constant LCU) of Madagascar?
Offer a terse response. 7.53e+1. What is the difference between the highest and the lowest Prive value of exports (constant LCU) of South Sudan?
Provide a short and direct response. 2.44e+1. What is the difference between the highest and the lowest Prive value of exports (constant LCU) of Uzbekistan?
Keep it short and to the point. 2.43e+11. 